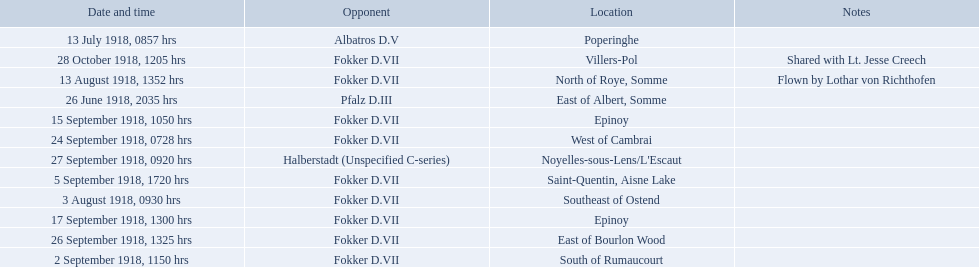Which opponent did kindley have the most victories against? Fokker D.VII. 